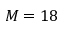Convert formula to latex. <formula><loc_0><loc_0><loc_500><loc_500>M = 1 8</formula> 